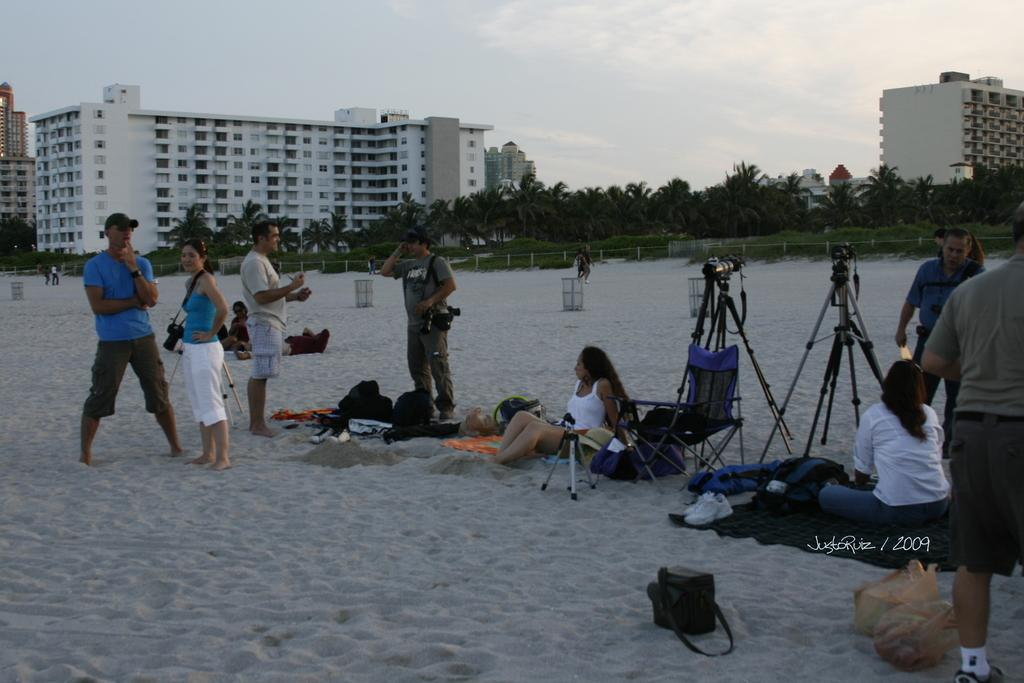What is the surface that the people are standing on in the image? The people are standing on the sand in the image. What objects are present that are typically used for capturing images? There are cameras in the image. What structures can be seen in the image that are used for displaying items or supporting equipment? There are stands in the image. What personal belongings are visible in the image? There are bags and shoes in the image. What objects are present for disposing of waste? There are bins in the image. What can be seen in the sky in the image? The sky is visible in the image. What type of vegetation is present in the image? There are trees in the image. What type of man-made structures can be seen in the image? There are buildings in the image. What type of barrier is present in the image? There is a fencing in the image. How many cacti are present in the image? There are no cacti present in the image. What type of nerve is visible in the image? There are no nerves visible in the image. 